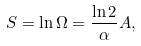<formula> <loc_0><loc_0><loc_500><loc_500>S = \ln \Omega = \frac { \ln 2 } { \alpha } A ,</formula> 